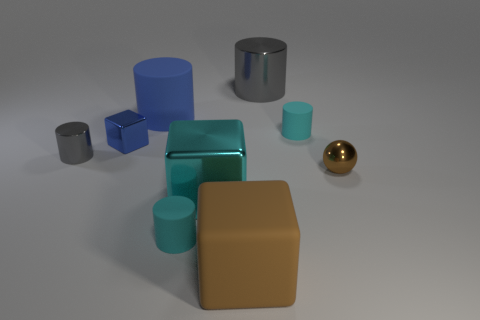What number of other objects are there of the same material as the small gray thing?
Offer a very short reply. 4. Do the small cyan rubber thing to the right of the large gray cylinder and the tiny object that is in front of the brown metallic sphere have the same shape?
Your answer should be very brief. Yes. What number of other objects are there of the same color as the metal sphere?
Offer a very short reply. 1. Is the small cyan cylinder that is in front of the tiny brown sphere made of the same material as the gray cylinder that is on the left side of the rubber block?
Keep it short and to the point. No. Are there an equal number of objects that are behind the tiny cube and cyan rubber objects right of the brown metallic thing?
Offer a terse response. No. What is the big thing that is to the left of the large cyan metallic thing made of?
Offer a very short reply. Rubber. Is there any other thing that is the same size as the ball?
Your answer should be compact. Yes. Are there fewer blue metal cylinders than gray cylinders?
Keep it short and to the point. Yes. What is the shape of the large object that is both behind the blue metal block and on the right side of the big blue cylinder?
Your response must be concise. Cylinder. How many small blue metal things are there?
Your response must be concise. 1. 